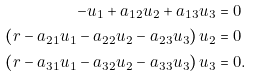<formula> <loc_0><loc_0><loc_500><loc_500>- u _ { 1 } + a _ { 1 2 } u _ { 2 } + a _ { 1 3 } u _ { 3 } & = 0 \\ \left ( r - a _ { 2 1 } u _ { 1 } - a _ { 2 2 } u _ { 2 } - a _ { 2 3 } u _ { 3 } \right ) u _ { 2 } & = 0 \\ \left ( r - a _ { 3 1 } u _ { 1 } - a _ { 3 2 } u _ { 2 } - a _ { 3 3 } u _ { 3 } \right ) u _ { 3 } & = 0 .</formula> 